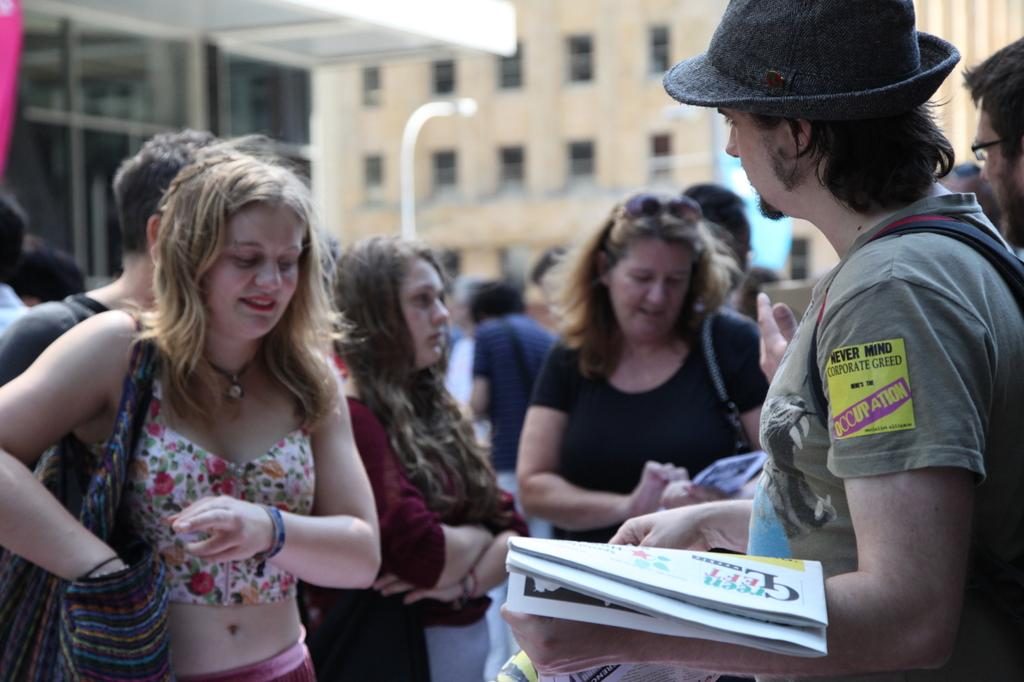How many people are in the image? There is a group of people in the image. What are the people doing in the image? The people are standing. What can be seen in the background of the image? There are buildings in the background of the image. What feature do the buildings have? The buildings have windows. What level of the building are the people standing on in the image? The provided facts do not mention the level of the building, so it cannot be determined from the image. Is there any indication of a war happening in the image? There is no indication of a war or any conflict in the image. 